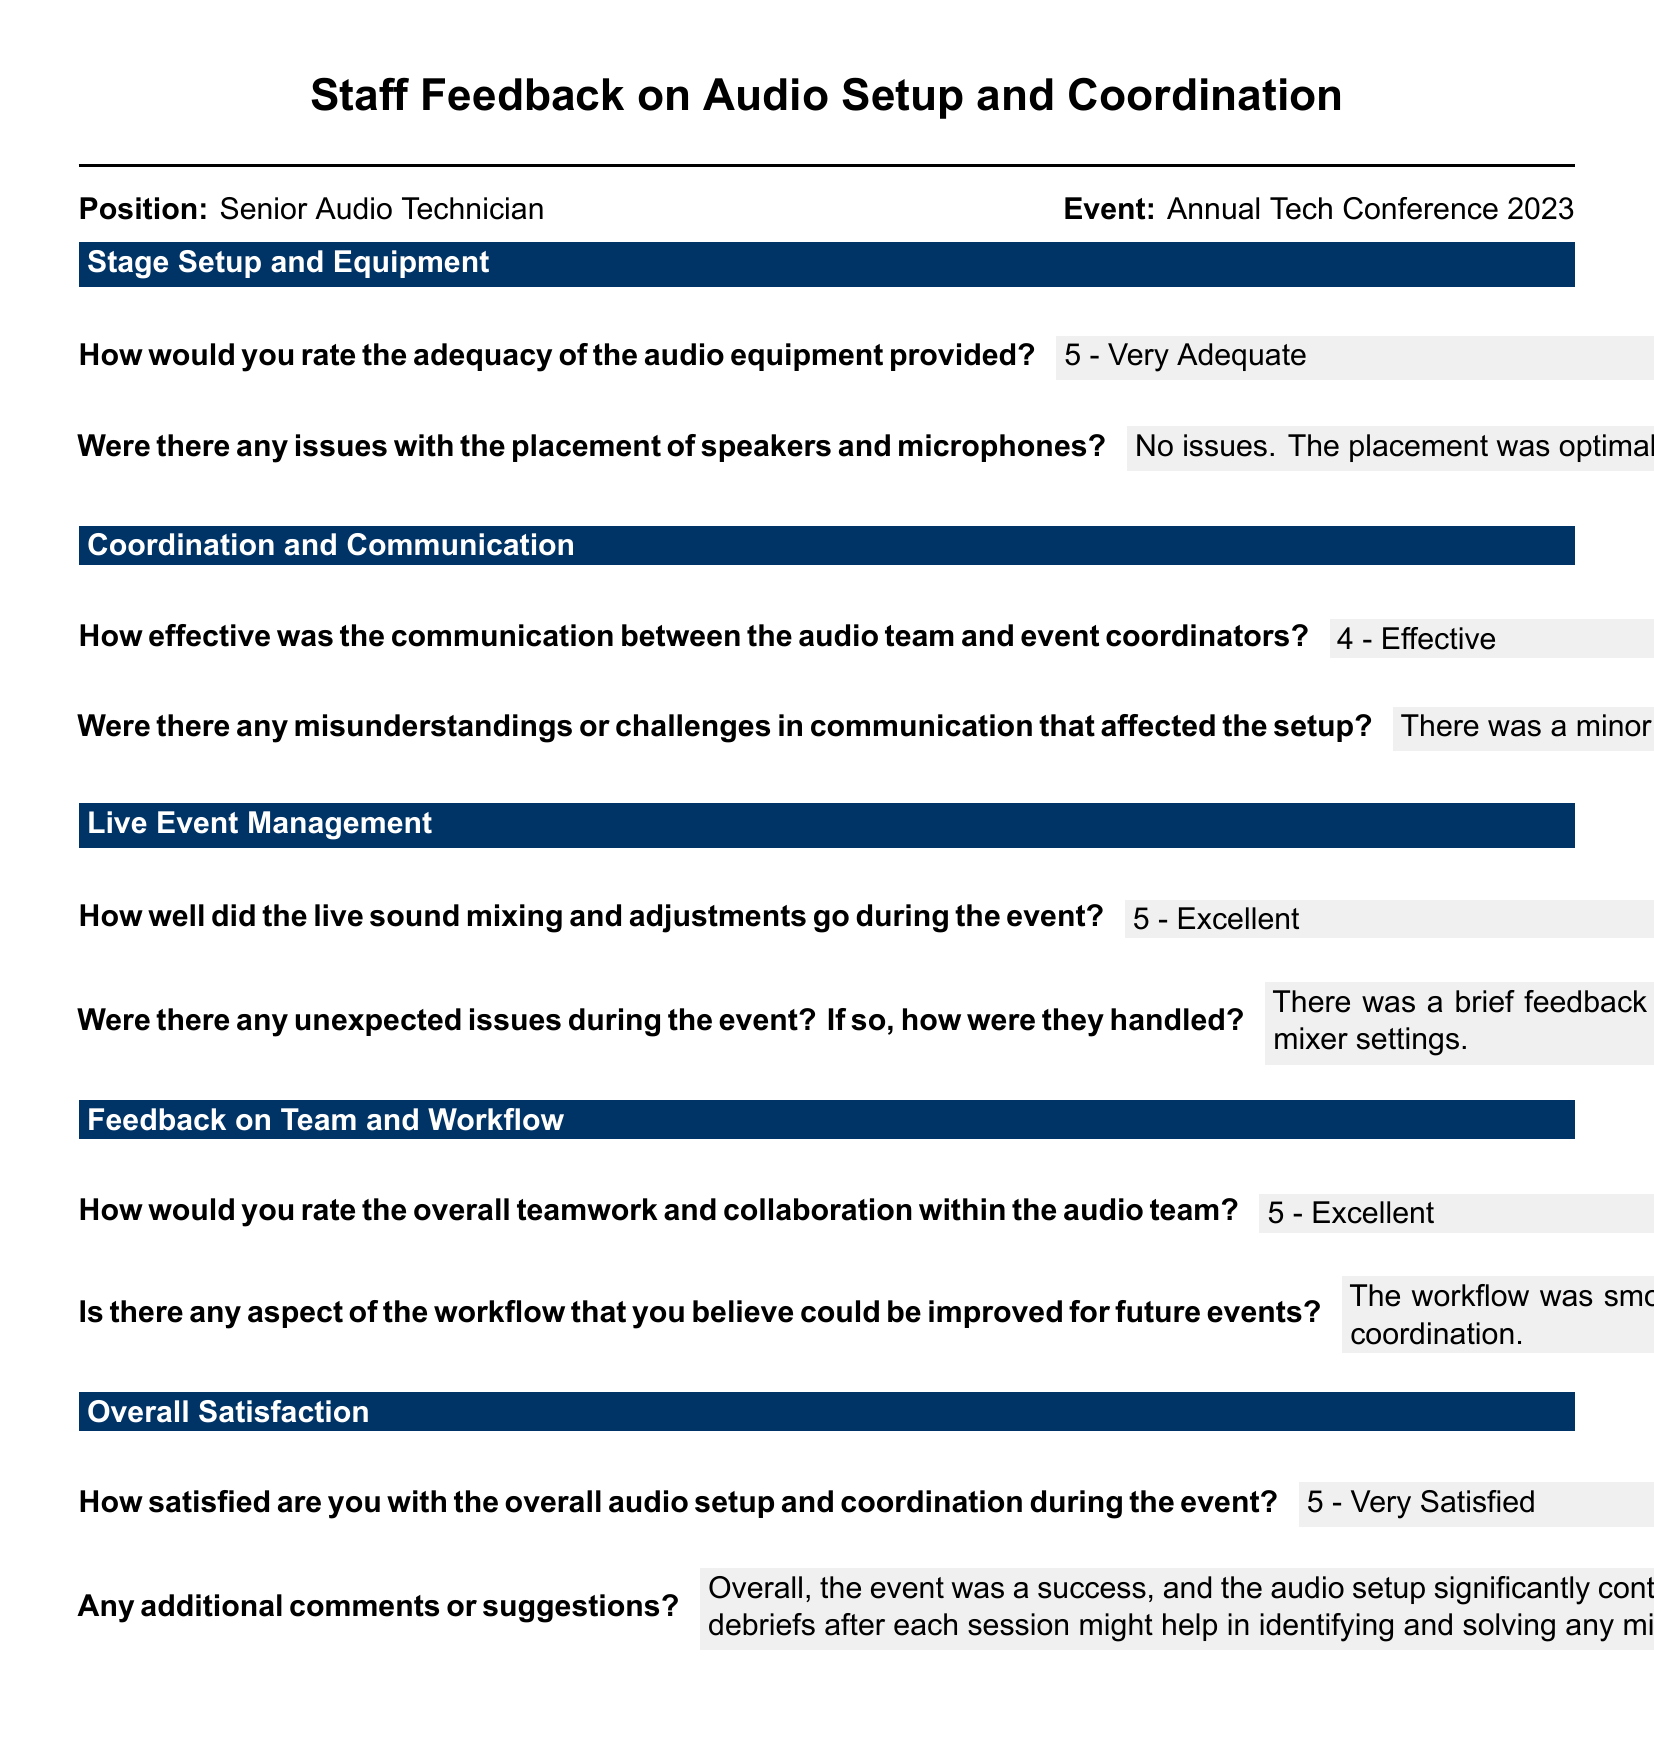What was the position of the individual providing feedback? The position is stated at the beginning of the document, which is Senior Audio Technician.
Answer: Senior Audio Technician What event is being referred to in the feedback? The event title is mentioned clearly, which is Annual Tech Conference 2023.
Answer: Annual Tech Conference 2023 How would the individual rate the adequacy of the audio equipment? The rating can be found in the section about Stage Setup and Equipment, which is 5.
Answer: 5 What was the rating for overall teamwork and collaboration within the audio team? This information is found in the Feedback on Team and Workflow section, which states a rating of 5.
Answer: 5 What minor issue occurred during the live event? The document mentions a feedback issue when switching microphones.
Answer: Feedback issue What suggestion was made for improving workflow in future events? The individual recommended incorporating a brief pre-event meeting as a potential improvement.
Answer: Pre-event meeting How satisfied was the individual with the overall audio setup and coordination? The satisfaction level is clearly rated in the Overall Satisfaction section, which is 5.
Answer: 5 What was the response regarding communication between the audio team and event coordinators? This response is articulated in the Coordination and Communication section as a rating of 4.
Answer: 4 How did the individual describe the live sound mixing during the event? The individual rated it as excellent in the live event management section.
Answer: Excellent 